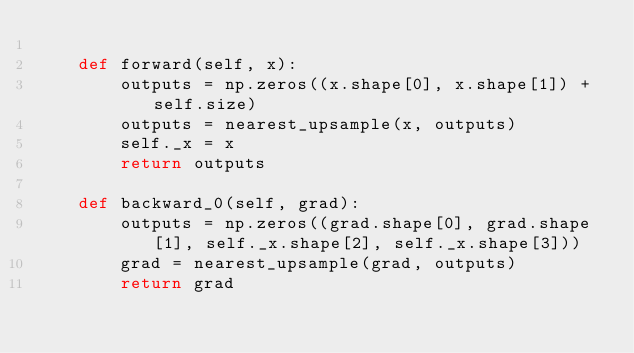Convert code to text. <code><loc_0><loc_0><loc_500><loc_500><_Python_>
    def forward(self, x):
        outputs = np.zeros((x.shape[0], x.shape[1]) + self.size)
        outputs = nearest_upsample(x, outputs)
        self._x = x
        return outputs

    def backward_0(self, grad):
        outputs = np.zeros((grad.shape[0], grad.shape[1], self._x.shape[2], self._x.shape[3]))
        grad = nearest_upsample(grad, outputs)
        return grad 
</code> 